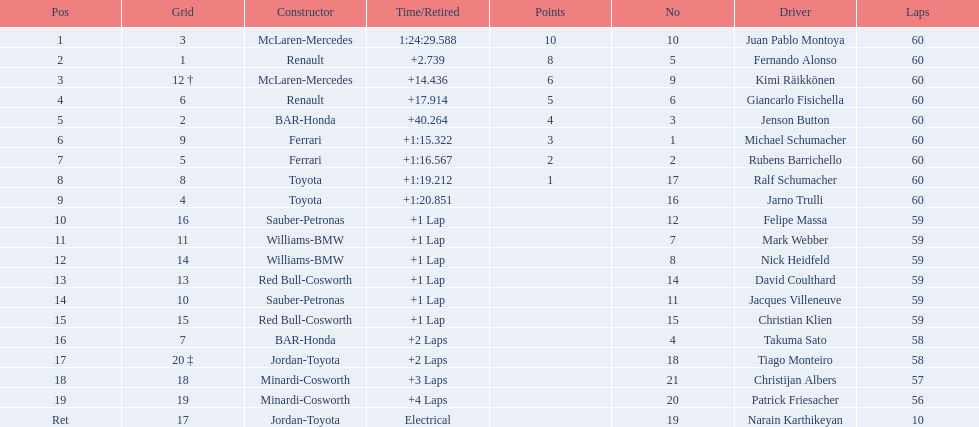After 8th position, how many points does a driver receive? 0. Give me the full table as a dictionary. {'header': ['Pos', 'Grid', 'Constructor', 'Time/Retired', 'Points', 'No', 'Driver', 'Laps'], 'rows': [['1', '3', 'McLaren-Mercedes', '1:24:29.588', '10', '10', 'Juan Pablo Montoya', '60'], ['2', '1', 'Renault', '+2.739', '8', '5', 'Fernando Alonso', '60'], ['3', '12 †', 'McLaren-Mercedes', '+14.436', '6', '9', 'Kimi Räikkönen', '60'], ['4', '6', 'Renault', '+17.914', '5', '6', 'Giancarlo Fisichella', '60'], ['5', '2', 'BAR-Honda', '+40.264', '4', '3', 'Jenson Button', '60'], ['6', '9', 'Ferrari', '+1:15.322', '3', '1', 'Michael Schumacher', '60'], ['7', '5', 'Ferrari', '+1:16.567', '2', '2', 'Rubens Barrichello', '60'], ['8', '8', 'Toyota', '+1:19.212', '1', '17', 'Ralf Schumacher', '60'], ['9', '4', 'Toyota', '+1:20.851', '', '16', 'Jarno Trulli', '60'], ['10', '16', 'Sauber-Petronas', '+1 Lap', '', '12', 'Felipe Massa', '59'], ['11', '11', 'Williams-BMW', '+1 Lap', '', '7', 'Mark Webber', '59'], ['12', '14', 'Williams-BMW', '+1 Lap', '', '8', 'Nick Heidfeld', '59'], ['13', '13', 'Red Bull-Cosworth', '+1 Lap', '', '14', 'David Coulthard', '59'], ['14', '10', 'Sauber-Petronas', '+1 Lap', '', '11', 'Jacques Villeneuve', '59'], ['15', '15', 'Red Bull-Cosworth', '+1 Lap', '', '15', 'Christian Klien', '59'], ['16', '7', 'BAR-Honda', '+2 Laps', '', '4', 'Takuma Sato', '58'], ['17', '20 ‡', 'Jordan-Toyota', '+2 Laps', '', '18', 'Tiago Monteiro', '58'], ['18', '18', 'Minardi-Cosworth', '+3 Laps', '', '21', 'Christijan Albers', '57'], ['19', '19', 'Minardi-Cosworth', '+4 Laps', '', '20', 'Patrick Friesacher', '56'], ['Ret', '17', 'Jordan-Toyota', 'Electrical', '', '19', 'Narain Karthikeyan', '10']]} 